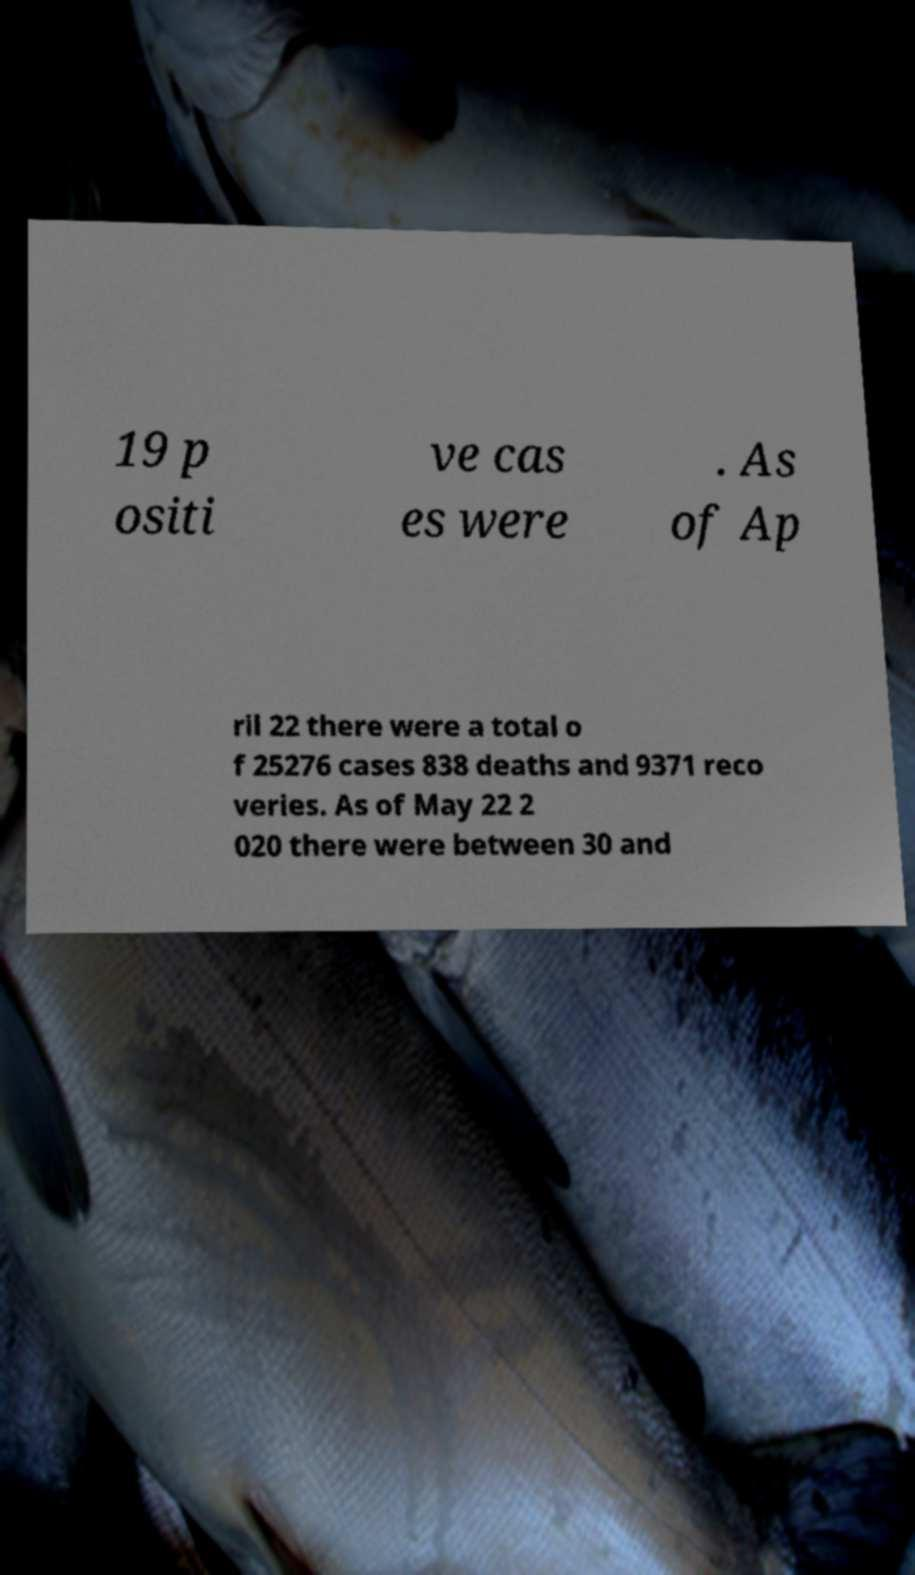Could you assist in decoding the text presented in this image and type it out clearly? 19 p ositi ve cas es were . As of Ap ril 22 there were a total o f 25276 cases 838 deaths and 9371 reco veries. As of May 22 2 020 there were between 30 and 